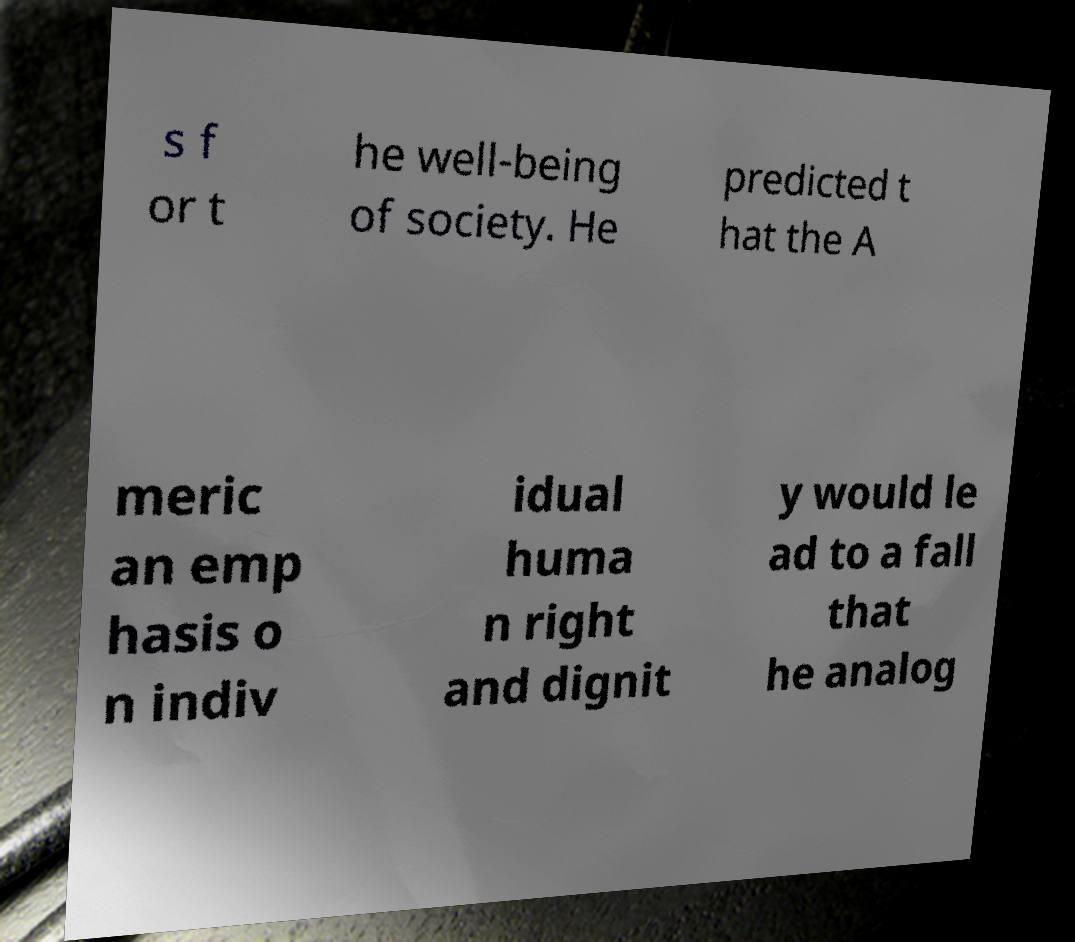Can you read and provide the text displayed in the image?This photo seems to have some interesting text. Can you extract and type it out for me? s f or t he well-being of society. He predicted t hat the A meric an emp hasis o n indiv idual huma n right and dignit y would le ad to a fall that he analog 